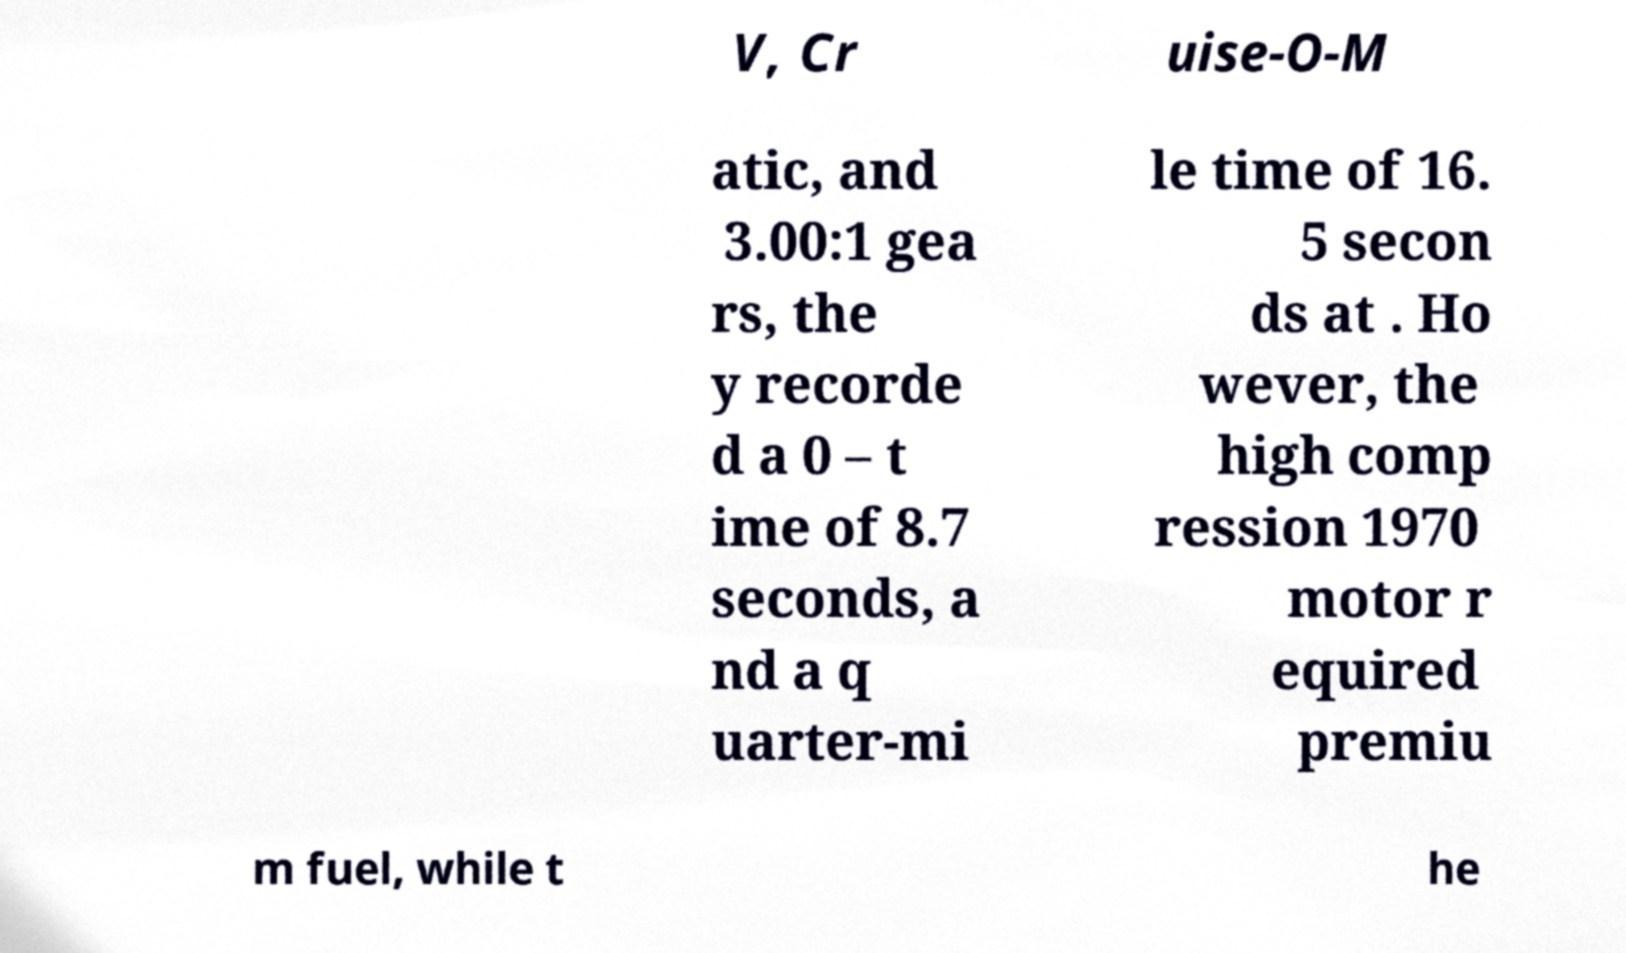Could you extract and type out the text from this image? V, Cr uise-O-M atic, and 3.00:1 gea rs, the y recorde d a 0 – t ime of 8.7 seconds, a nd a q uarter-mi le time of 16. 5 secon ds at . Ho wever, the high comp ression 1970 motor r equired premiu m fuel, while t he 